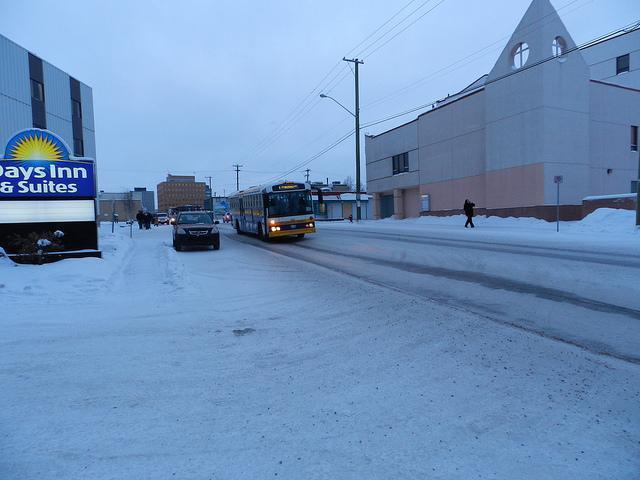What kind of building is the one with the sign on the left?
Make your selection and explain in format: 'Answer: answer
Rationale: rationale.'
Options: Hotel, restaurant, pub, library. Answer: hotel.
Rationale: The sign is for a hotel. 